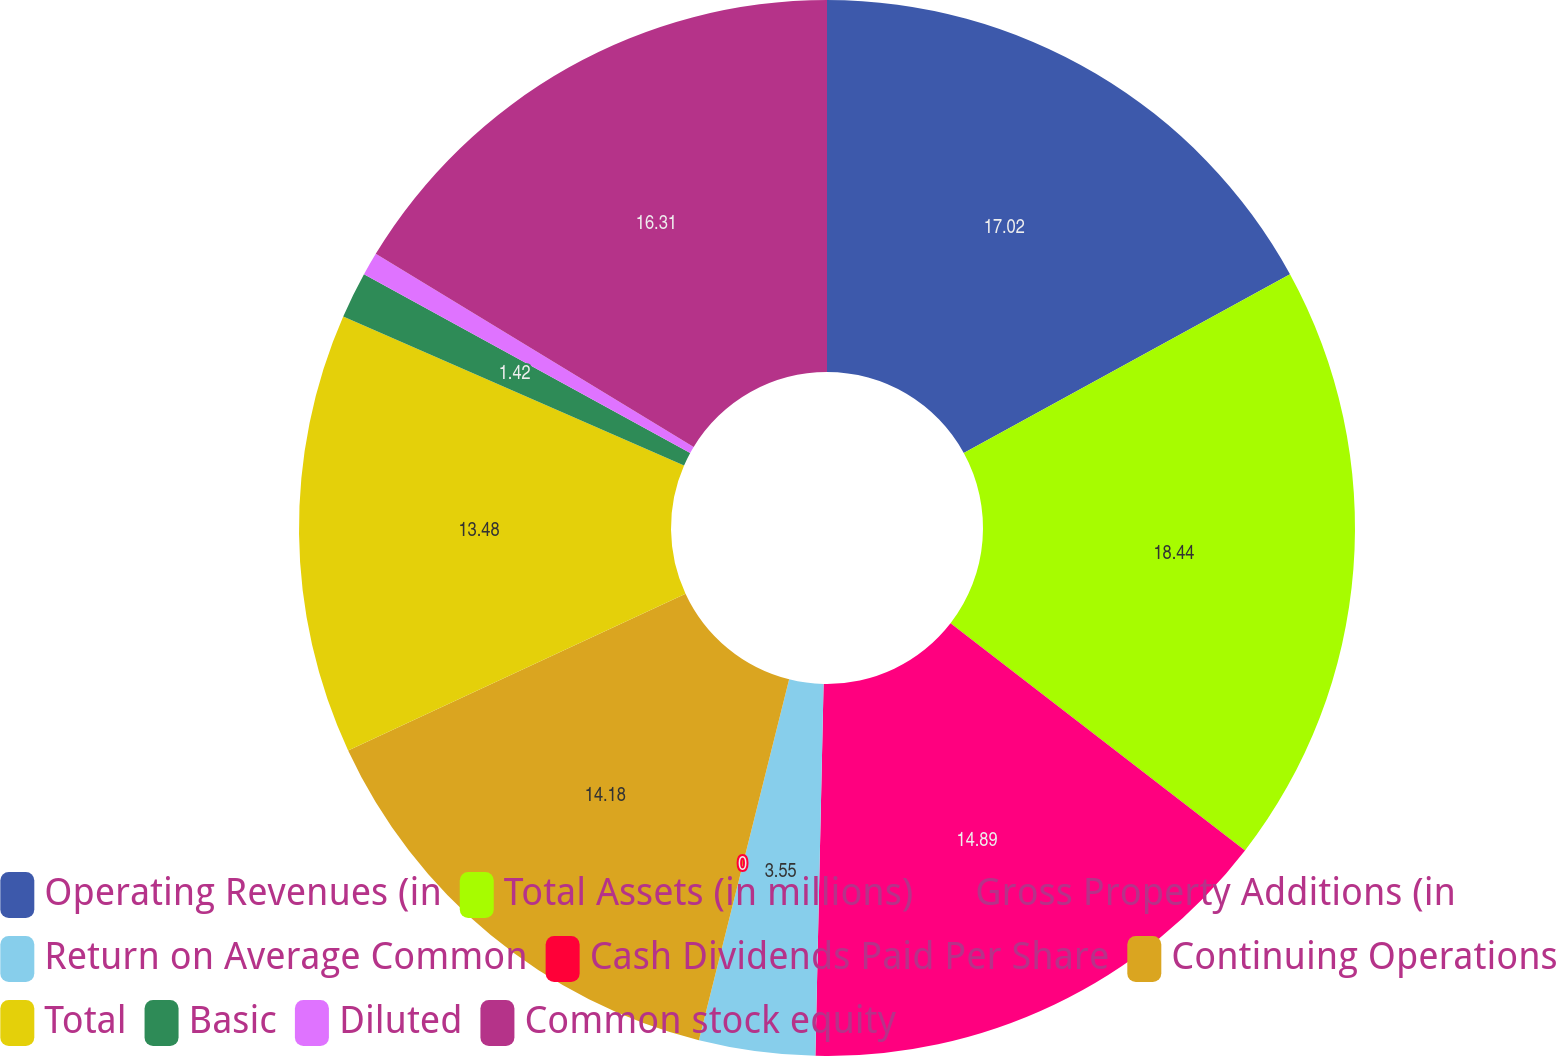Convert chart. <chart><loc_0><loc_0><loc_500><loc_500><pie_chart><fcel>Operating Revenues (in<fcel>Total Assets (in millions)<fcel>Gross Property Additions (in<fcel>Return on Average Common<fcel>Cash Dividends Paid Per Share<fcel>Continuing Operations<fcel>Total<fcel>Basic<fcel>Diluted<fcel>Common stock equity<nl><fcel>17.02%<fcel>18.44%<fcel>14.89%<fcel>3.55%<fcel>0.0%<fcel>14.18%<fcel>13.48%<fcel>1.42%<fcel>0.71%<fcel>16.31%<nl></chart> 